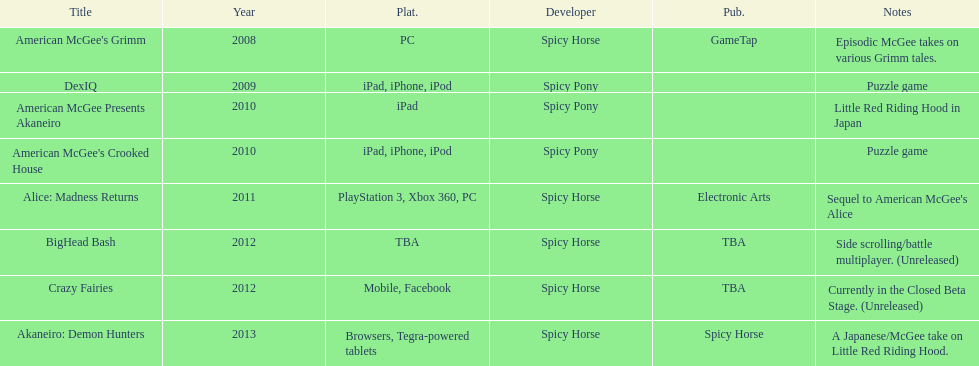What was the most recent game produced by spicy horse? Akaneiro: Demon Hunters. Could you parse the entire table? {'header': ['Title', 'Year', 'Plat.', 'Developer', 'Pub.', 'Notes'], 'rows': [["American McGee's Grimm", '2008', 'PC', 'Spicy Horse', 'GameTap', 'Episodic McGee takes on various Grimm tales.'], ['DexIQ', '2009', 'iPad, iPhone, iPod', 'Spicy Pony', '', 'Puzzle game'], ['American McGee Presents Akaneiro', '2010', 'iPad', 'Spicy Pony', '', 'Little Red Riding Hood in Japan'], ["American McGee's Crooked House", '2010', 'iPad, iPhone, iPod', 'Spicy Pony', '', 'Puzzle game'], ['Alice: Madness Returns', '2011', 'PlayStation 3, Xbox 360, PC', 'Spicy Horse', 'Electronic Arts', "Sequel to American McGee's Alice"], ['BigHead Bash', '2012', 'TBA', 'Spicy Horse', 'TBA', 'Side scrolling/battle multiplayer. (Unreleased)'], ['Crazy Fairies', '2012', 'Mobile, Facebook', 'Spicy Horse', 'TBA', 'Currently in the Closed Beta Stage. (Unreleased)'], ['Akaneiro: Demon Hunters', '2013', 'Browsers, Tegra-powered tablets', 'Spicy Horse', 'Spicy Horse', 'A Japanese/McGee take on Little Red Riding Hood.']]} 